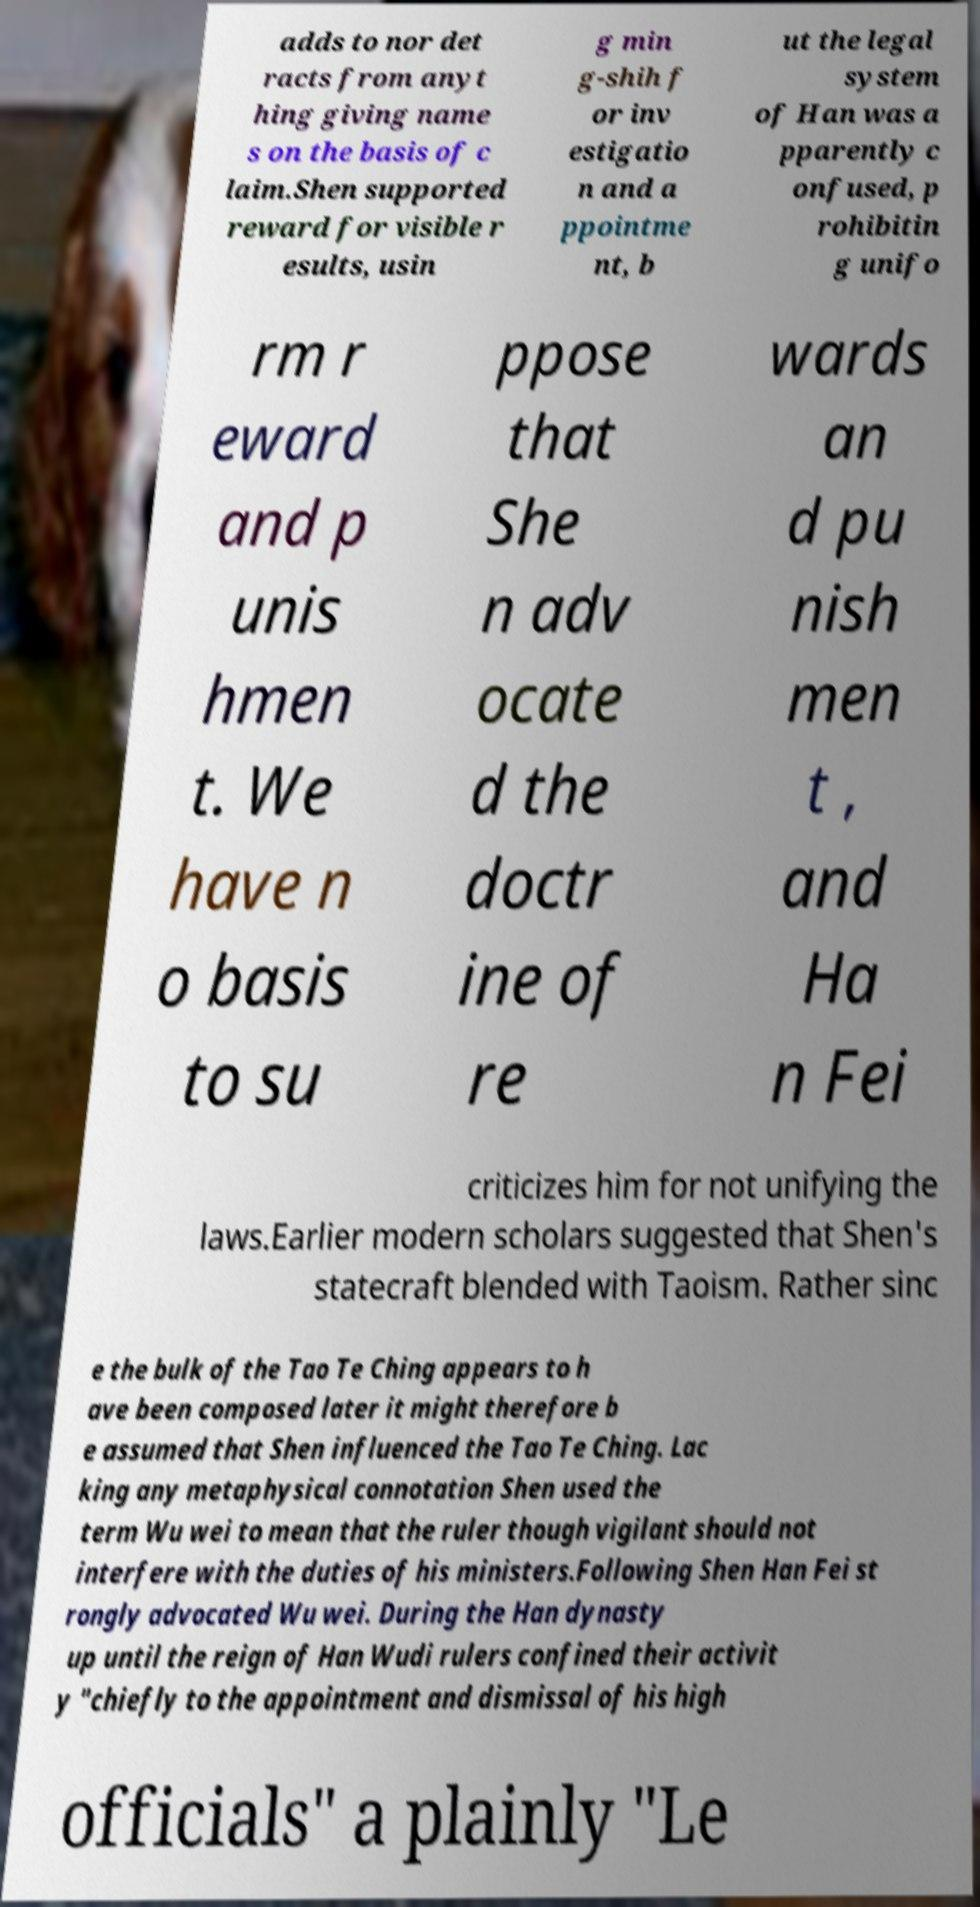Please identify and transcribe the text found in this image. adds to nor det racts from anyt hing giving name s on the basis of c laim.Shen supported reward for visible r esults, usin g min g-shih f or inv estigatio n and a ppointme nt, b ut the legal system of Han was a pparently c onfused, p rohibitin g unifo rm r eward and p unis hmen t. We have n o basis to su ppose that She n adv ocate d the doctr ine of re wards an d pu nish men t , and Ha n Fei criticizes him for not unifying the laws.Earlier modern scholars suggested that Shen's statecraft blended with Taoism. Rather sinc e the bulk of the Tao Te Ching appears to h ave been composed later it might therefore b e assumed that Shen influenced the Tao Te Ching. Lac king any metaphysical connotation Shen used the term Wu wei to mean that the ruler though vigilant should not interfere with the duties of his ministers.Following Shen Han Fei st rongly advocated Wu wei. During the Han dynasty up until the reign of Han Wudi rulers confined their activit y "chiefly to the appointment and dismissal of his high officials" a plainly "Le 